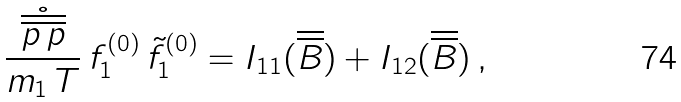<formula> <loc_0><loc_0><loc_500><loc_500>\frac { \mathring { \overline { \overline { p \, p } } } } { m _ { 1 } \, T } \, f _ { 1 } ^ { ( 0 ) } \, \tilde { f } _ { 1 } ^ { ( 0 ) } = I _ { 1 1 } ( \overline { \overline { B } } ) + I _ { 1 2 } ( \overline { \overline { B } } ) \, ,</formula> 